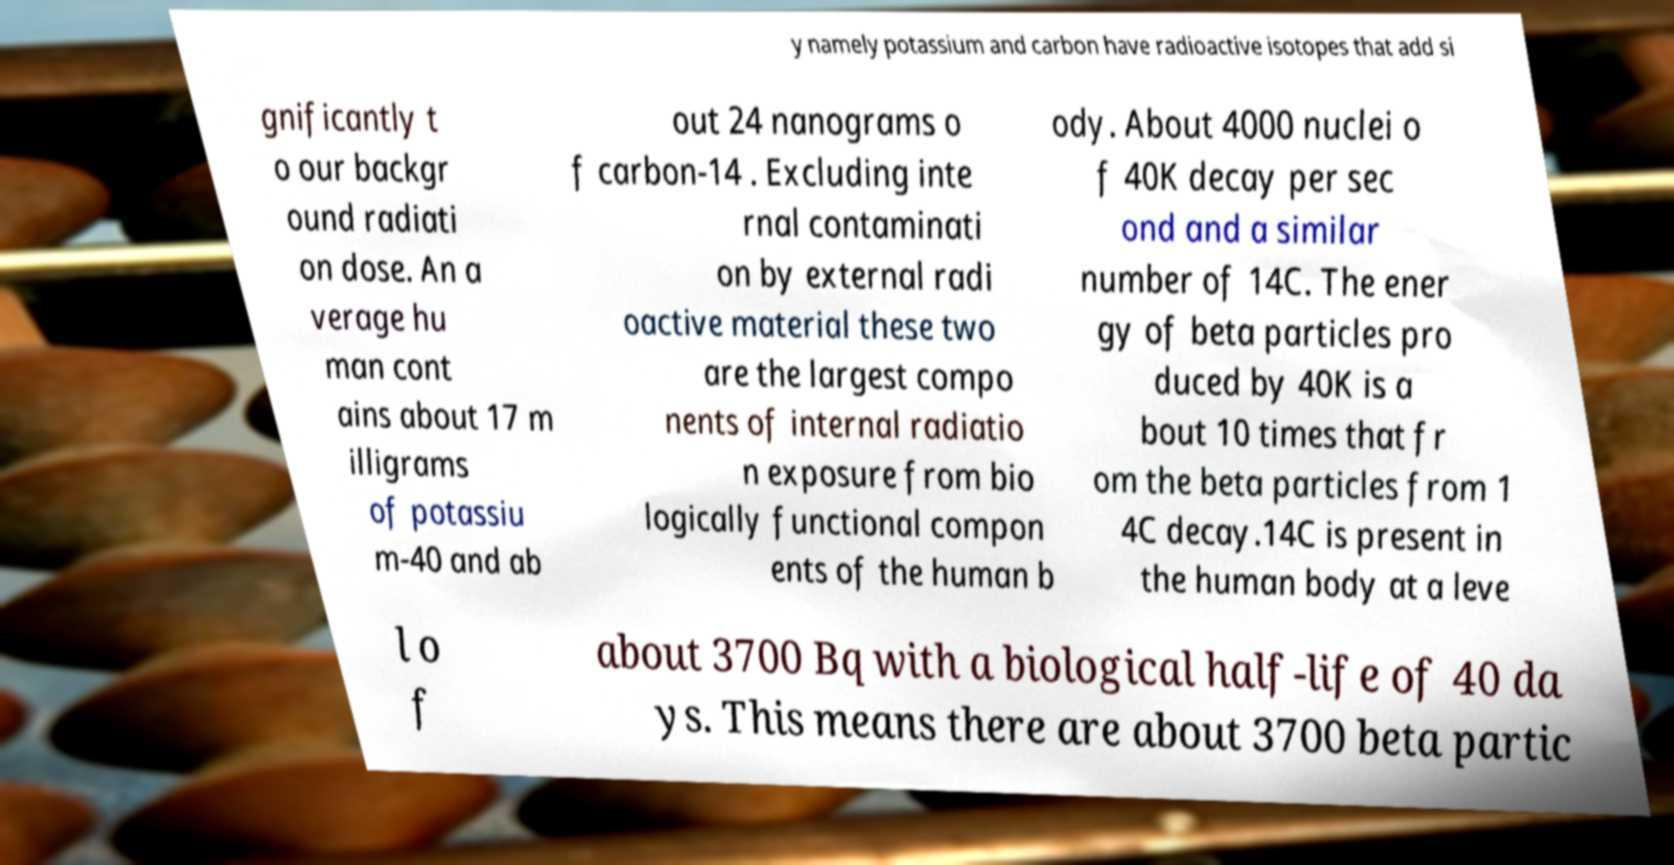There's text embedded in this image that I need extracted. Can you transcribe it verbatim? y namely potassium and carbon have radioactive isotopes that add si gnificantly t o our backgr ound radiati on dose. An a verage hu man cont ains about 17 m illigrams of potassiu m-40 and ab out 24 nanograms o f carbon-14 . Excluding inte rnal contaminati on by external radi oactive material these two are the largest compo nents of internal radiatio n exposure from bio logically functional compon ents of the human b ody. About 4000 nuclei o f 40K decay per sec ond and a similar number of 14C. The ener gy of beta particles pro duced by 40K is a bout 10 times that fr om the beta particles from 1 4C decay.14C is present in the human body at a leve l o f about 3700 Bq with a biological half-life of 40 da ys. This means there are about 3700 beta partic 